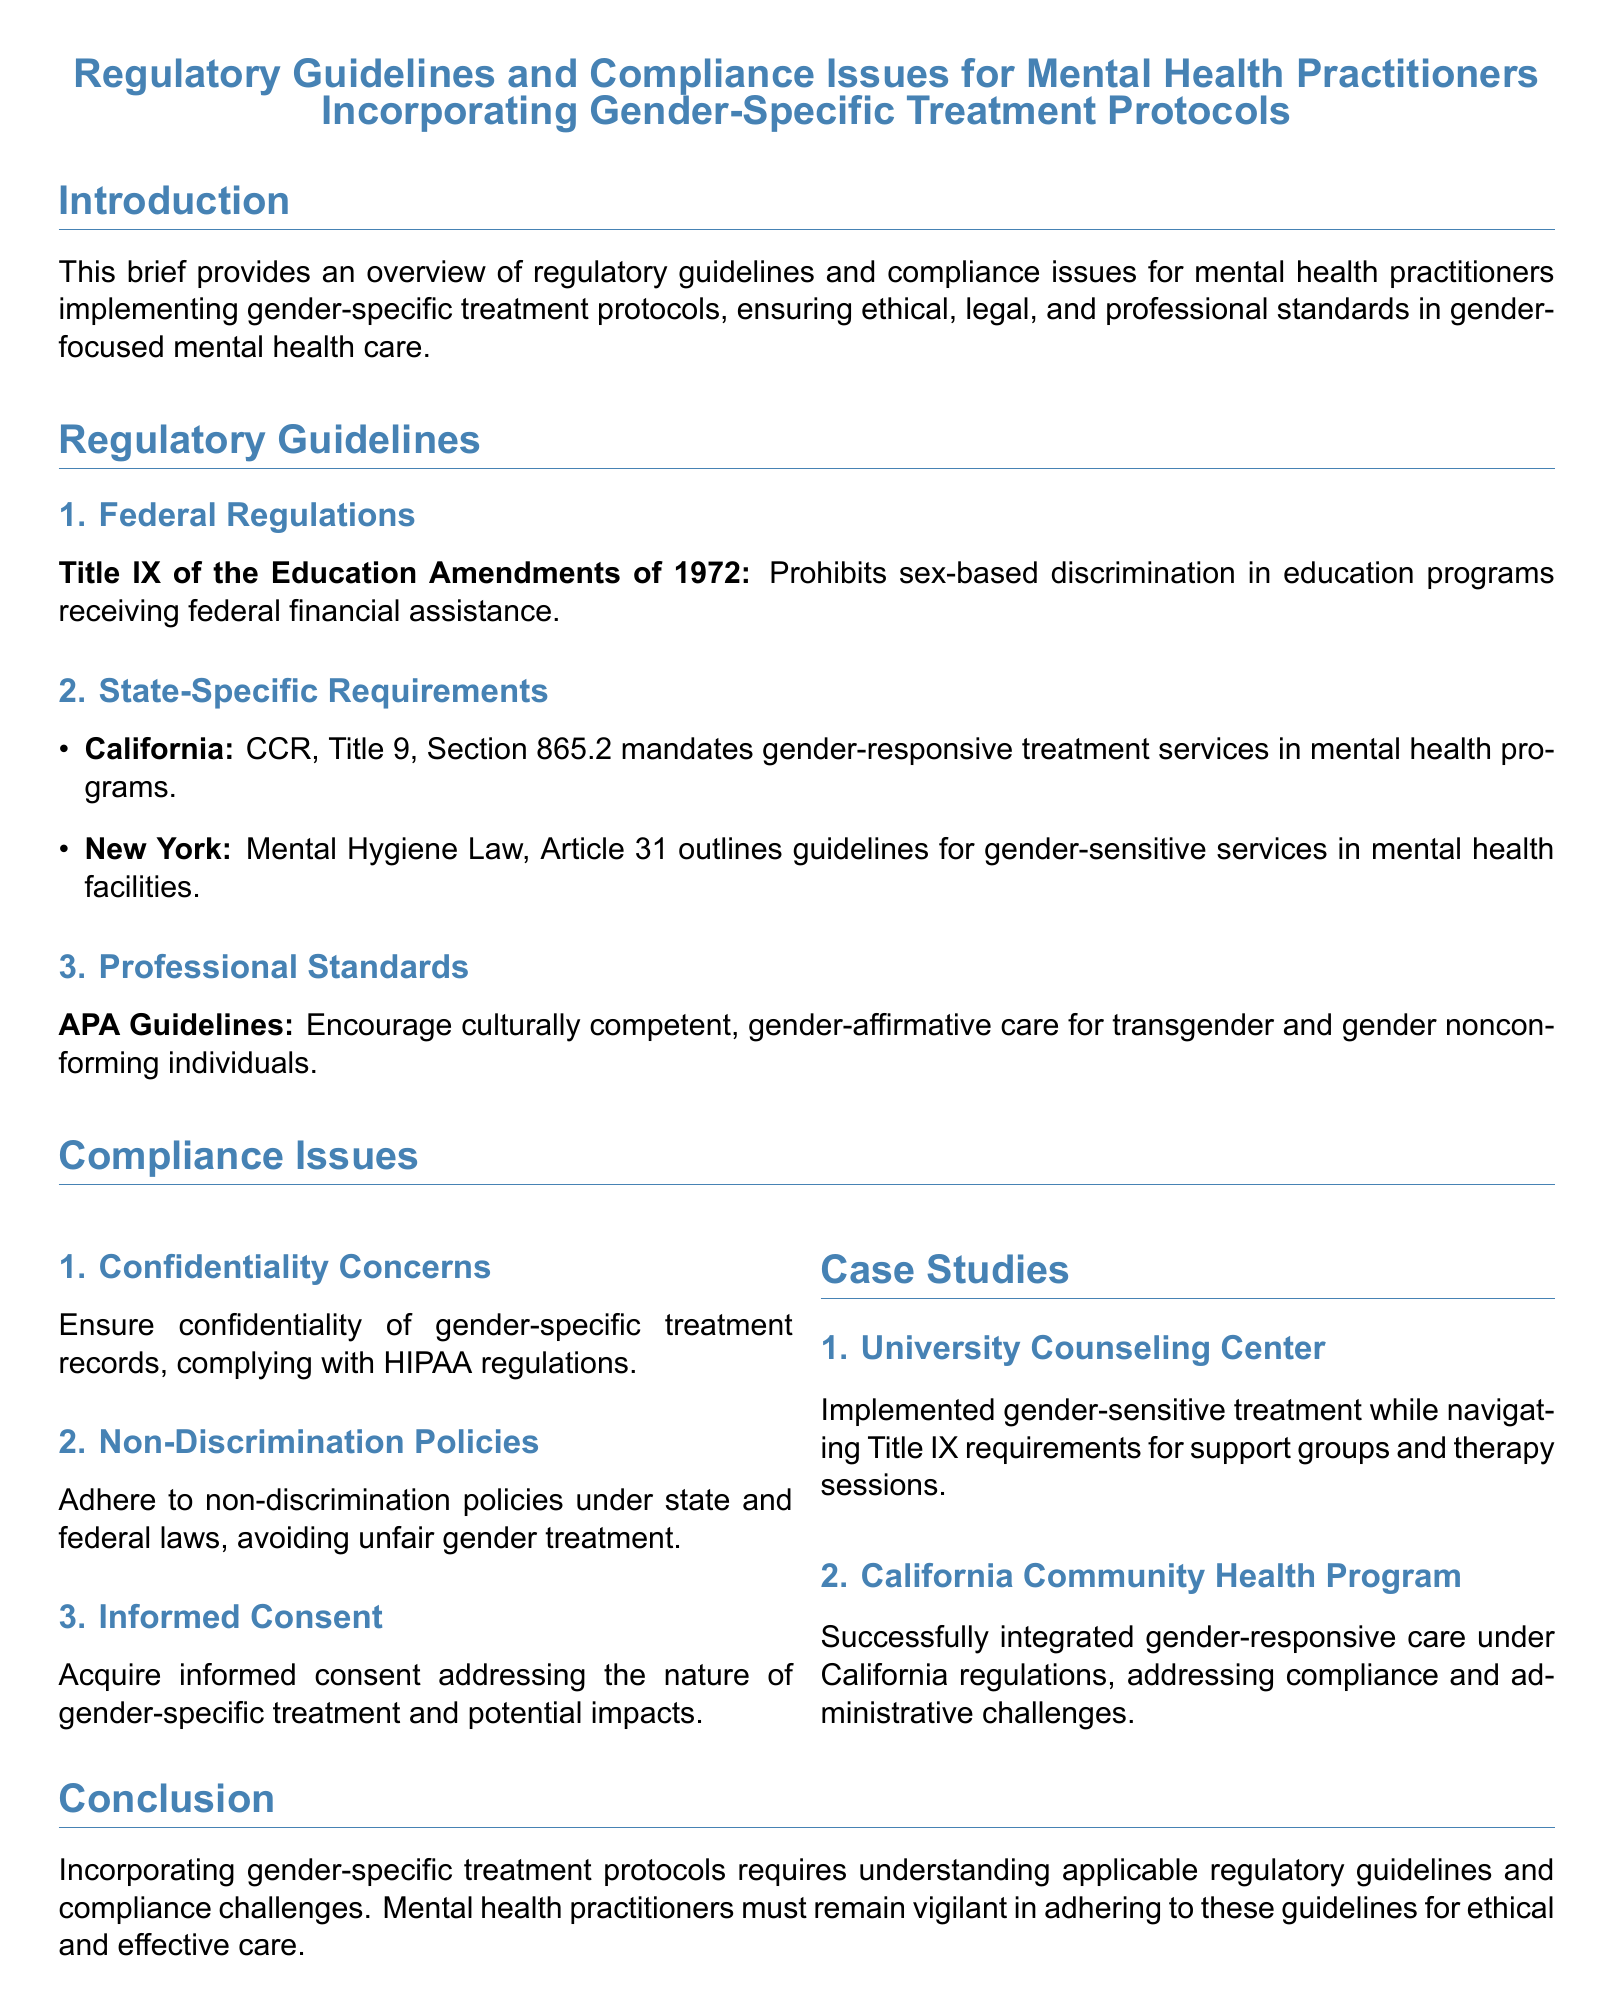What federal regulation prohibits sex-based discrimination in education? Title IX of the Education Amendments of 1972 prohibits sex-based discrimination in education programs receiving federal financial assistance.
Answer: Title IX What is mandated in California's mental health programs? CCR, Title 9, Section 865.2 mandates gender-responsive treatment services in mental health programs.
Answer: Gender-responsive treatment services What document encourages culturally competent, gender-affirmative care? The APA Guidelines encourage culturally competent, gender-affirmative care for transgender and gender nonconforming individuals.
Answer: APA Guidelines What is a compliance issue related to gender-specific treatment records? Ensuring confidentiality of gender-specific treatment records, complying with HIPAA regulations is a compliance issue.
Answer: Confidentiality Which state's law outlines guidelines for gender-sensitive services? New York's Mental Hygiene Law, Article 31 outlines guidelines for gender-sensitive services in mental health facilities.
Answer: New York What type of consent should be acquired for gender-specific treatment? Informed consent addressing the nature of gender-specific treatment and potential impacts should be acquired.
Answer: Informed consent What is the title of the legal brief? The title of the legal brief provides an overview of regulatory guidelines and compliance issues for mental health practitioners incorporating gender-specific treatment protocols.
Answer: Regulatory Guidelines and Compliance Issues for Mental Health Practitioners Incorporating Gender-Specific Treatment Protocols How many case studies are mentioned in the brief? Two case studies are mentioned: University Counseling Center and California Community Health Program.
Answer: Two 